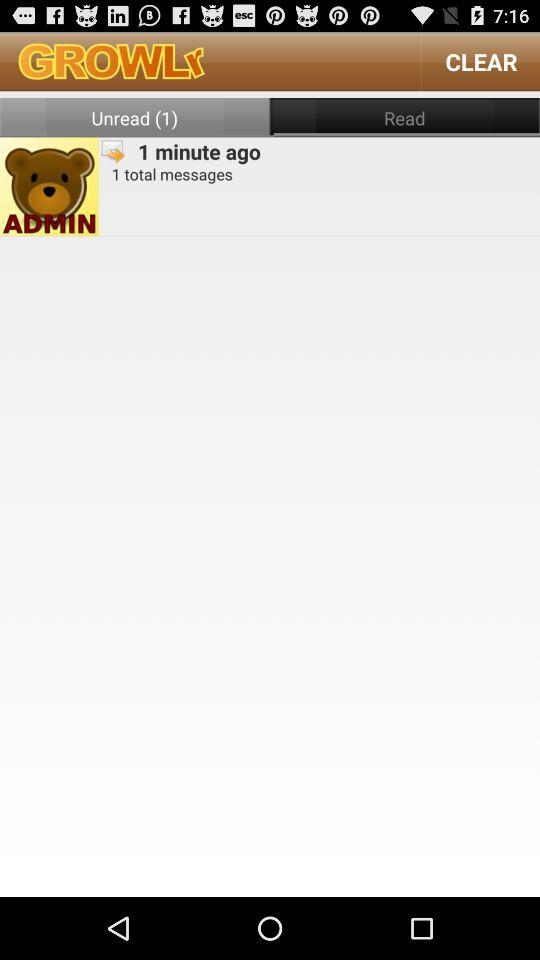What is the total number of messages? The total number of messages is 1. 